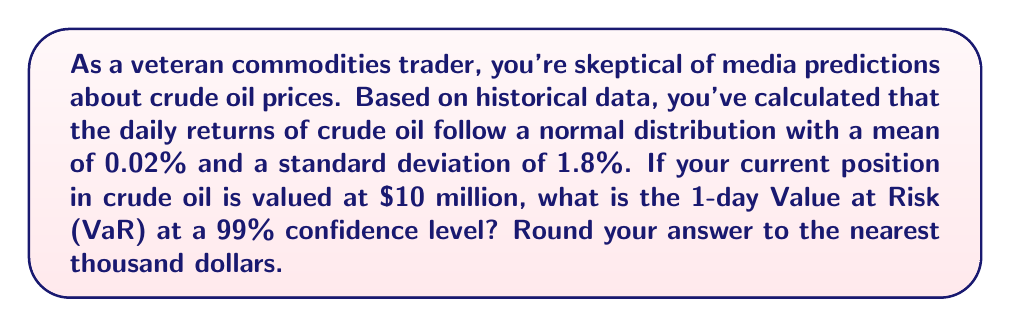Can you solve this math problem? To solve this problem, we'll use the Value at Risk (VaR) calculation based on the normal distribution of returns. Here's a step-by-step approach:

1) The VaR formula for a normal distribution is:

   $$VaR = P * Z * \sigma - \mu * P$$

   Where:
   $P$ is the portfolio value
   $Z$ is the Z-score for the desired confidence level
   $\sigma$ is the standard deviation of returns
   $\mu$ is the mean of returns

2) We're given:
   $P = \$10,000,000$
   $\sigma = 1.8\%$ = 0.018
   $\mu = 0.02\%$ = 0.0002
   Confidence level = 99%

3) For a 99% confidence level, the Z-score is 2.326 (this can be found in a standard normal distribution table or calculated using statistical software)

4) Plugging these values into the formula:

   $$VaR = 10,000,000 * 2.326 * 0.018 - 0.0002 * 10,000,000$$

5) Calculating:
   $$VaR = 418,680 - 2,000 = 416,680$$

6) Rounding to the nearest thousand:
   $$VaR \approx \$417,000$$

This means that with 99% confidence, the maximum loss on this position over a 1-day period is expected to be no more than $417,000.
Answer: $417,000 